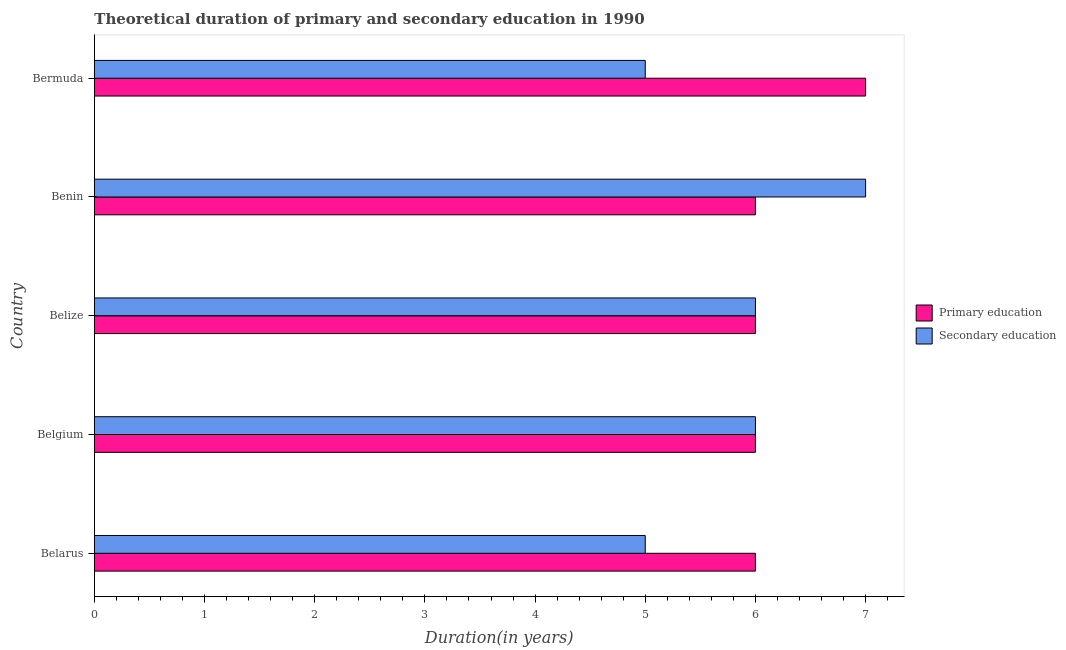How many different coloured bars are there?
Your answer should be very brief. 2. How many bars are there on the 2nd tick from the bottom?
Give a very brief answer. 2. What is the duration of primary education in Bermuda?
Offer a very short reply. 7. Across all countries, what is the maximum duration of secondary education?
Your answer should be compact. 7. Across all countries, what is the minimum duration of secondary education?
Provide a succinct answer. 5. In which country was the duration of secondary education maximum?
Your answer should be compact. Benin. In which country was the duration of secondary education minimum?
Offer a very short reply. Belarus. What is the total duration of secondary education in the graph?
Provide a short and direct response. 29. What is the difference between the duration of primary education in Belgium and that in Bermuda?
Ensure brevity in your answer.  -1. What is the difference between the duration of secondary education in Benin and the duration of primary education in Belgium?
Give a very brief answer. 1. What is the average duration of primary education per country?
Your answer should be very brief. 6.2. What is the difference between the duration of secondary education and duration of primary education in Belize?
Give a very brief answer. 0. What is the difference between the highest and the second highest duration of primary education?
Your answer should be compact. 1. What is the difference between the highest and the lowest duration of primary education?
Offer a very short reply. 1. What does the 1st bar from the top in Benin represents?
Provide a short and direct response. Secondary education. What does the 2nd bar from the bottom in Bermuda represents?
Your answer should be compact. Secondary education. How many bars are there?
Give a very brief answer. 10. Are all the bars in the graph horizontal?
Provide a short and direct response. Yes. How many countries are there in the graph?
Provide a short and direct response. 5. What is the difference between two consecutive major ticks on the X-axis?
Provide a short and direct response. 1. Does the graph contain grids?
Give a very brief answer. No. How many legend labels are there?
Your answer should be compact. 2. What is the title of the graph?
Your answer should be very brief. Theoretical duration of primary and secondary education in 1990. What is the label or title of the X-axis?
Your response must be concise. Duration(in years). What is the label or title of the Y-axis?
Ensure brevity in your answer.  Country. What is the Duration(in years) of Primary education in Belarus?
Your answer should be compact. 6. What is the Duration(in years) of Secondary education in Belarus?
Ensure brevity in your answer.  5. What is the Duration(in years) of Secondary education in Belize?
Keep it short and to the point. 6. What is the Duration(in years) in Secondary education in Benin?
Ensure brevity in your answer.  7. What is the Duration(in years) in Secondary education in Bermuda?
Offer a very short reply. 5. What is the total Duration(in years) in Primary education in the graph?
Your answer should be very brief. 31. What is the difference between the Duration(in years) of Primary education in Belarus and that in Belgium?
Provide a short and direct response. 0. What is the difference between the Duration(in years) of Secondary education in Belarus and that in Belgium?
Your response must be concise. -1. What is the difference between the Duration(in years) of Primary education in Belarus and that in Belize?
Provide a short and direct response. 0. What is the difference between the Duration(in years) in Secondary education in Belarus and that in Belize?
Give a very brief answer. -1. What is the difference between the Duration(in years) of Primary education in Belarus and that in Benin?
Give a very brief answer. 0. What is the difference between the Duration(in years) of Secondary education in Belarus and that in Bermuda?
Provide a short and direct response. 0. What is the difference between the Duration(in years) in Secondary education in Belgium and that in Belize?
Offer a terse response. 0. What is the difference between the Duration(in years) in Primary education in Belgium and that in Benin?
Your answer should be compact. 0. What is the difference between the Duration(in years) in Primary education in Belgium and that in Bermuda?
Provide a succinct answer. -1. What is the difference between the Duration(in years) in Secondary education in Belgium and that in Bermuda?
Your response must be concise. 1. What is the difference between the Duration(in years) in Primary education in Belize and that in Benin?
Provide a short and direct response. 0. What is the difference between the Duration(in years) in Secondary education in Belize and that in Benin?
Keep it short and to the point. -1. What is the difference between the Duration(in years) of Primary education in Benin and that in Bermuda?
Offer a terse response. -1. What is the difference between the Duration(in years) in Secondary education in Benin and that in Bermuda?
Offer a very short reply. 2. What is the difference between the Duration(in years) in Primary education in Belarus and the Duration(in years) in Secondary education in Benin?
Provide a succinct answer. -1. What is the difference between the Duration(in years) of Primary education in Belarus and the Duration(in years) of Secondary education in Bermuda?
Offer a terse response. 1. What is the difference between the Duration(in years) in Primary education in Belgium and the Duration(in years) in Secondary education in Benin?
Provide a short and direct response. -1. What is the difference between the Duration(in years) of Primary education in Belgium and the Duration(in years) of Secondary education in Bermuda?
Make the answer very short. 1. What is the difference between the Duration(in years) in Primary education in Belize and the Duration(in years) in Secondary education in Benin?
Offer a very short reply. -1. What is the difference between the Duration(in years) in Primary education in Benin and the Duration(in years) in Secondary education in Bermuda?
Your answer should be very brief. 1. What is the difference between the Duration(in years) in Primary education and Duration(in years) in Secondary education in Belgium?
Your answer should be very brief. 0. What is the ratio of the Duration(in years) of Primary education in Belarus to that in Belgium?
Make the answer very short. 1. What is the ratio of the Duration(in years) in Secondary education in Belarus to that in Belize?
Provide a succinct answer. 0.83. What is the ratio of the Duration(in years) in Secondary education in Belarus to that in Benin?
Your answer should be compact. 0.71. What is the ratio of the Duration(in years) in Primary education in Belarus to that in Bermuda?
Offer a terse response. 0.86. What is the ratio of the Duration(in years) in Secondary education in Belarus to that in Bermuda?
Your answer should be very brief. 1. What is the ratio of the Duration(in years) in Primary education in Belgium to that in Belize?
Give a very brief answer. 1. What is the ratio of the Duration(in years) of Primary education in Belgium to that in Benin?
Offer a very short reply. 1. What is the ratio of the Duration(in years) of Primary education in Belize to that in Bermuda?
Make the answer very short. 0.86. What is the ratio of the Duration(in years) in Secondary education in Belize to that in Bermuda?
Your answer should be compact. 1.2. What is the ratio of the Duration(in years) of Secondary education in Benin to that in Bermuda?
Keep it short and to the point. 1.4. What is the difference between the highest and the second highest Duration(in years) of Primary education?
Your answer should be compact. 1. What is the difference between the highest and the lowest Duration(in years) in Primary education?
Offer a very short reply. 1. What is the difference between the highest and the lowest Duration(in years) in Secondary education?
Your answer should be compact. 2. 